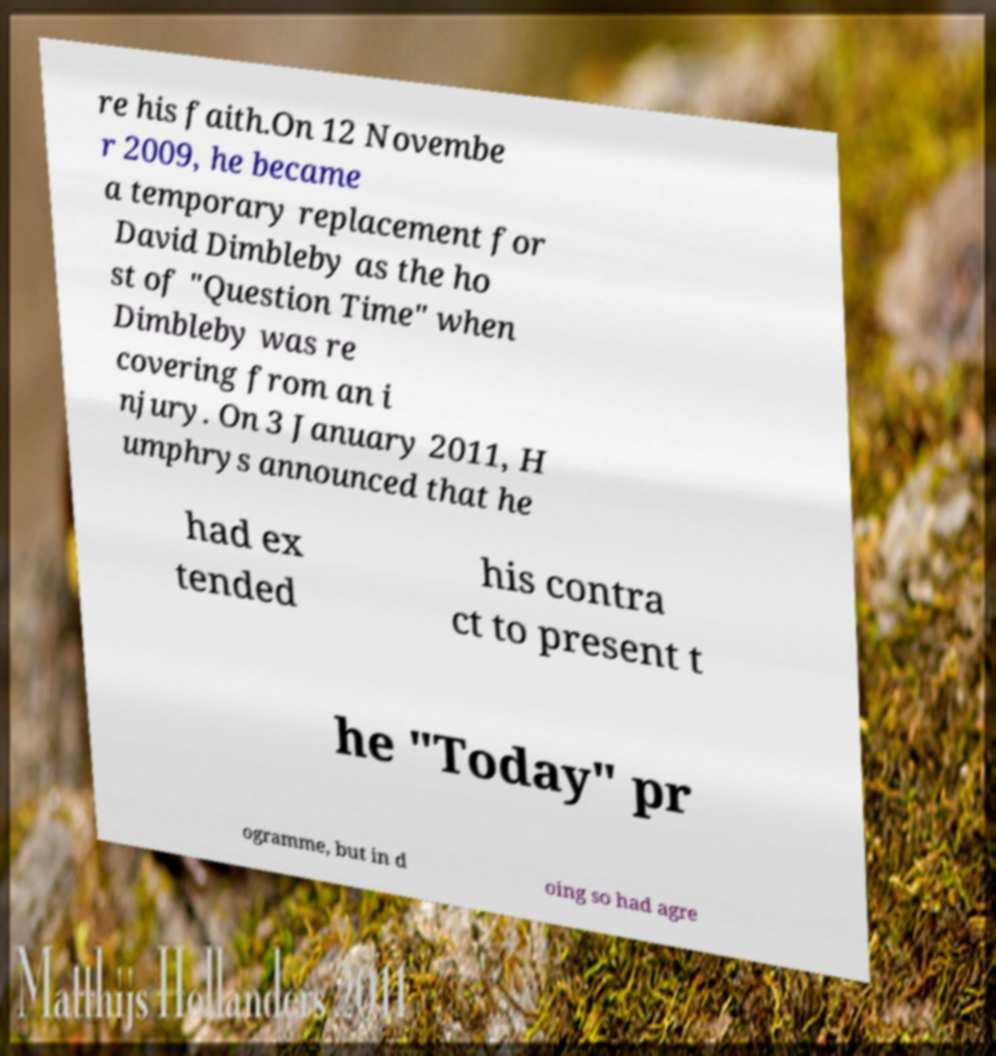Please read and relay the text visible in this image. What does it say? re his faith.On 12 Novembe r 2009, he became a temporary replacement for David Dimbleby as the ho st of "Question Time" when Dimbleby was re covering from an i njury. On 3 January 2011, H umphrys announced that he had ex tended his contra ct to present t he "Today" pr ogramme, but in d oing so had agre 